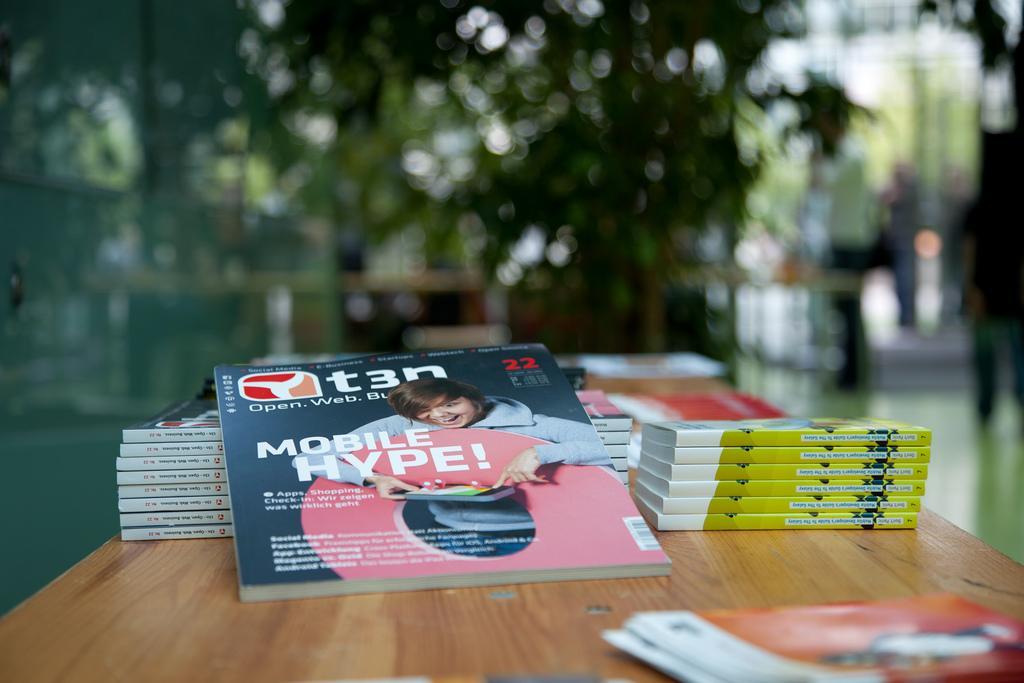Could you give a brief overview of what you see in this image? In this image there are books on the table. At the back there is a tree and at the right there is a person. 